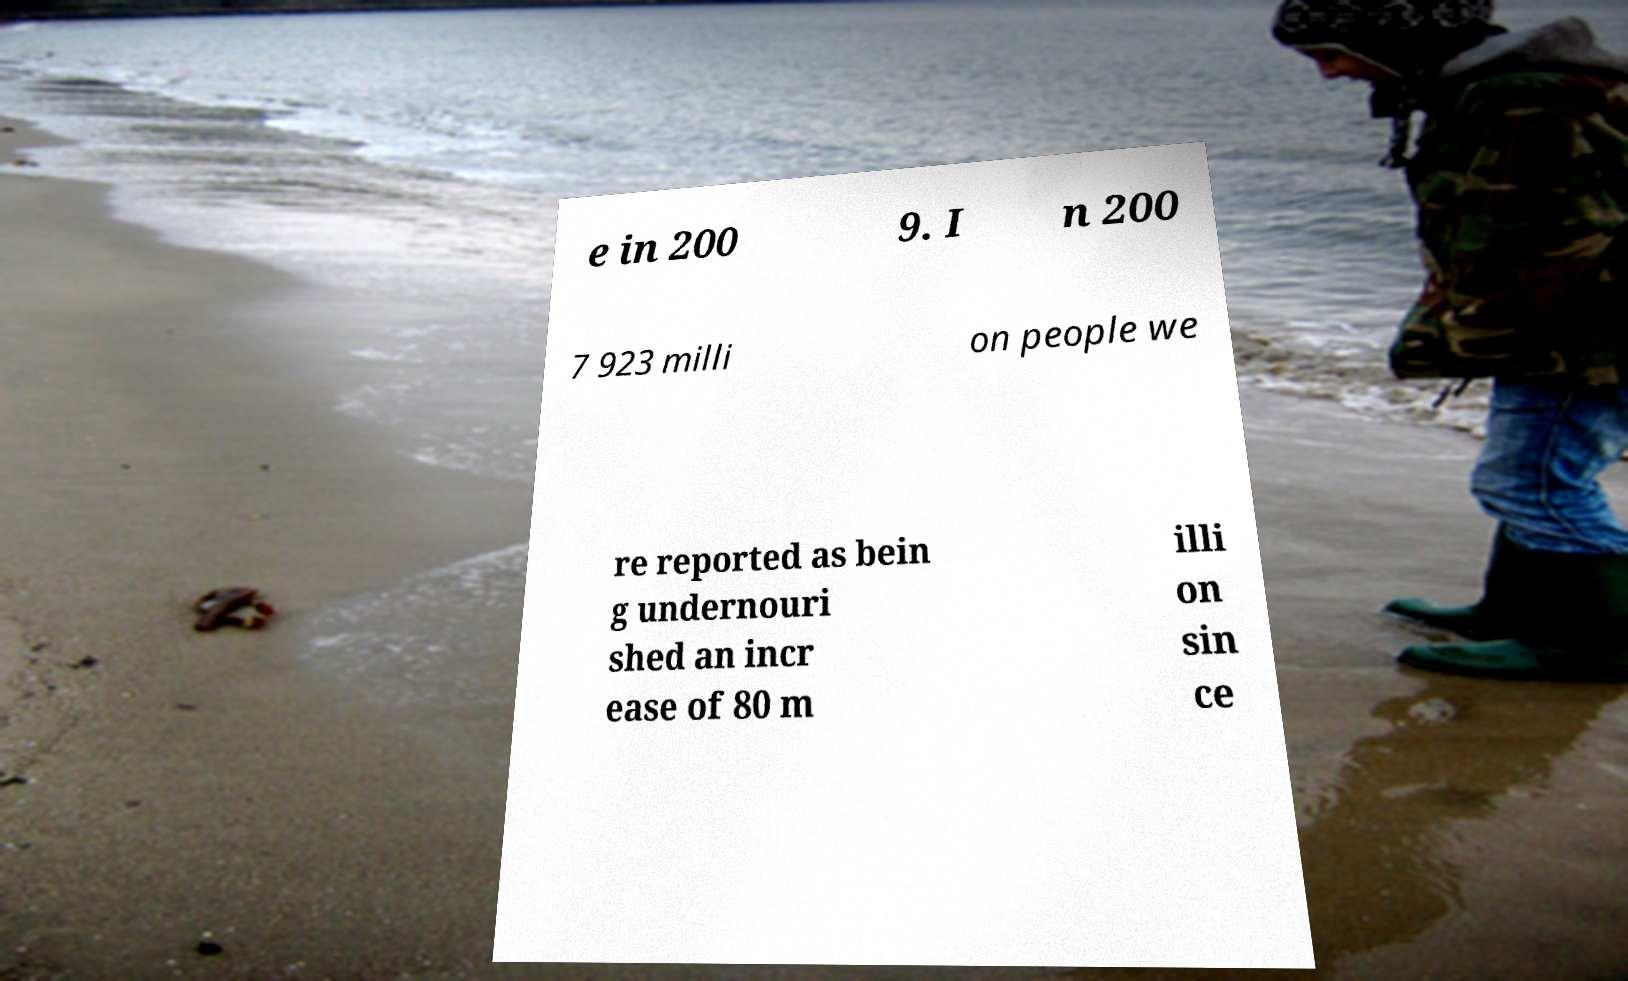Could you assist in decoding the text presented in this image and type it out clearly? e in 200 9. I n 200 7 923 milli on people we re reported as bein g undernouri shed an incr ease of 80 m illi on sin ce 